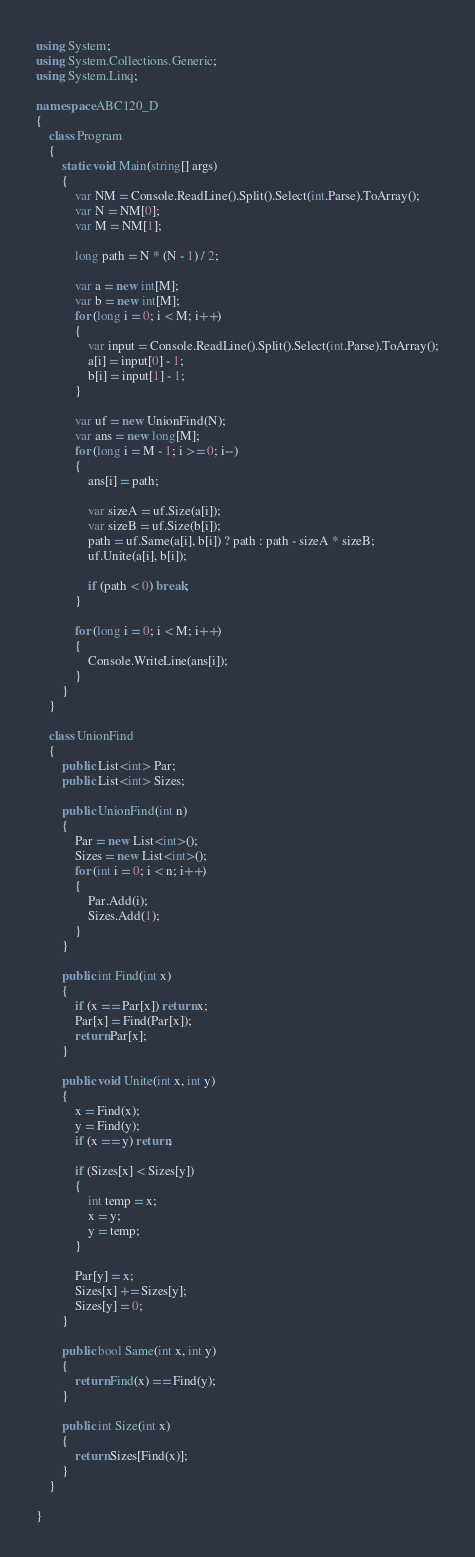<code> <loc_0><loc_0><loc_500><loc_500><_C#_>using System;
using System.Collections.Generic;
using System.Linq;

namespace ABC120_D
{
    class Program
    {
        static void Main(string[] args)
        {
            var NM = Console.ReadLine().Split().Select(int.Parse).ToArray();
            var N = NM[0];
            var M = NM[1];

            long path = N * (N - 1) / 2;

            var a = new int[M];
            var b = new int[M];
            for (long i = 0; i < M; i++)
            {
                var input = Console.ReadLine().Split().Select(int.Parse).ToArray();
                a[i] = input[0] - 1;
                b[i] = input[1] - 1;
            }

            var uf = new UnionFind(N);
            var ans = new long[M];
            for (long i = M - 1; i >= 0; i--)
            {
                ans[i] = path;

                var sizeA = uf.Size(a[i]);
                var sizeB = uf.Size(b[i]);
                path = uf.Same(a[i], b[i]) ? path : path - sizeA * sizeB;
                uf.Unite(a[i], b[i]);

                if (path < 0) break;
            }

            for (long i = 0; i < M; i++)
            {
                Console.WriteLine(ans[i]);
            }
        }
    }

    class UnionFind
    {
        public List<int> Par;
        public List<int> Sizes;

        public UnionFind(int n)
        {
            Par = new List<int>();
            Sizes = new List<int>();
            for (int i = 0; i < n; i++)
            {
                Par.Add(i);
                Sizes.Add(1);
            }
        }

        public int Find(int x)
        {
            if (x == Par[x]) return x;
            Par[x] = Find(Par[x]);
            return Par[x];
        }

        public void Unite(int x, int y)
        {
            x = Find(x);
            y = Find(y);
            if (x == y) return;

            if (Sizes[x] < Sizes[y])
            {
                int temp = x;
                x = y;
                y = temp;
            }

            Par[y] = x;
            Sizes[x] += Sizes[y];
            Sizes[y] = 0;
        }

        public bool Same(int x, int y)
        {
            return Find(x) == Find(y);
        }

        public int Size(int x)
        {
            return Sizes[Find(x)];
        }
    }

}</code> 